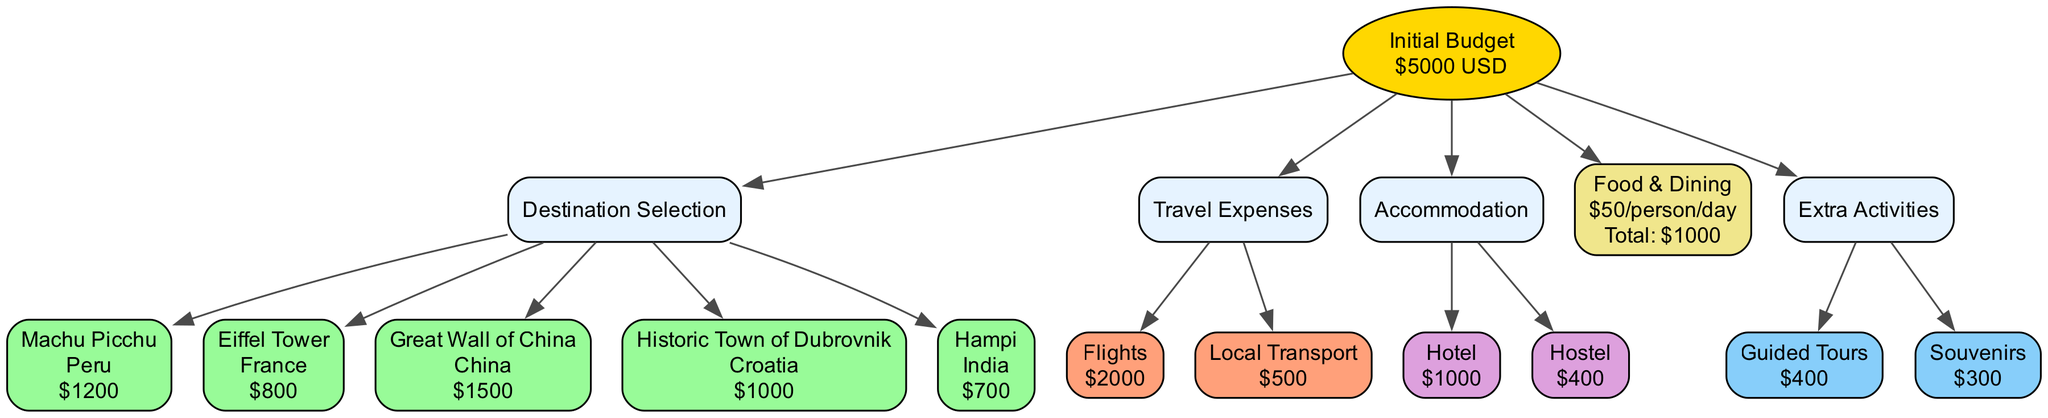What is the initial budget amount? The diagram states that the initial budget is set at $5000 USD. This information is presented in the root node of the diagram.
Answer: 5000 USD How many popular sites are listed? The diagram includes three nodes under the popular sites category, specifically Machu Picchu, Eiffel Tower, and Great Wall of China. This is counted directly from the respective section of the diagram.
Answer: 3 What is the cost estimate for a guided tour? The node for guided tours shows that the cost estimate is $400. This value can be found in the extra activities section of the diagram.
Answer: 400 What is the total estimate for food and dining? The total estimate for food and dining is $1000, which is indicated in the food and dining section based on the calculation for daily budget.
Answer: 1000 Which type of accommodation has the higher cost estimate? The diagram presents two accommodation options: Hotel at $1000 and Hostel at $400. Comparing these, Hotel is the option with the higher cost estimate.
Answer: Hotel If choosing Machu Picchu, what would the total expenses be including travel and accommodation? To calculate the total, we add the cost estimate for Machu Picchu ($1200), travel expenses (Flights $2000 + Local Transport $500), and accommodation (Hotel $1000). The total becomes $1200 + $2000 + $500 + $1000 = $3700. This is determined through the summation of the related costs.
Answer: 3700 What is the total cost for visiting both the Great Wall of China and the Eiffel Tower? The combined total cost entails Great Wall of China ($1500) and Eiffel Tower ($800). Adding these amounts ($1500 + $800) gives a total of $2300. This is calculated by directly summing the cost estimates from each node.
Answer: 2300 Which destination has the lowest cost estimate? From the given costs, Hampi has the lowest cost estimate at $700. This is determined by comparing all the listed cost estimates within the destination selection section.
Answer: Hampi What would be the total expenses if staying at a hostel instead of a hotel? To find this, we consider the total costs of Macchu Picchu ($1200), travel ($2000 + $500), and hostel accommodation ($400), leading to a total: $1200 + $2000 + $500 + $400 = $4100. This calculation uses the alternative accommodation option.
Answer: 4100 